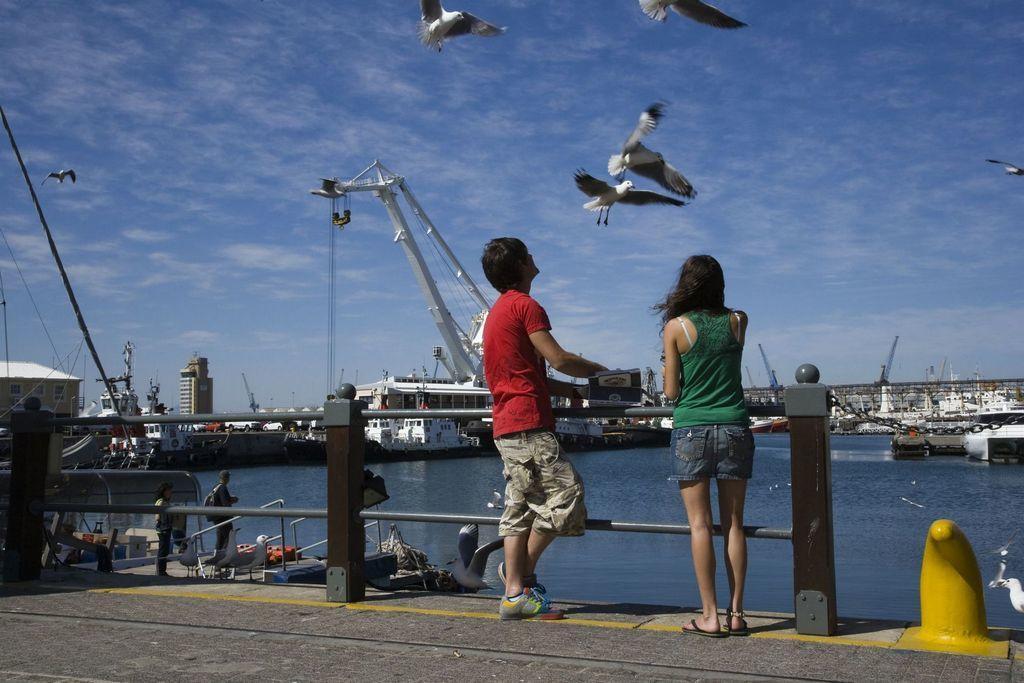Can you describe this image briefly? In this image we can see there are people standing on the ground. And there is a fence, water, ships, boat, and there are birds flying in the sky. 